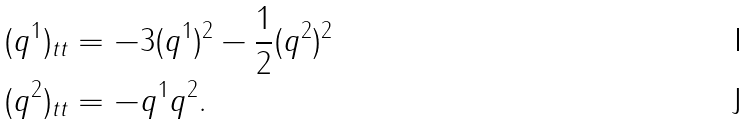Convert formula to latex. <formula><loc_0><loc_0><loc_500><loc_500>( q ^ { 1 } ) _ { t t } & = - 3 ( q ^ { 1 } ) ^ { 2 } - \frac { 1 } { 2 } ( q ^ { 2 } ) ^ { 2 } \\ ( q ^ { 2 } ) _ { t t } & = - q ^ { 1 } q ^ { 2 } .</formula> 